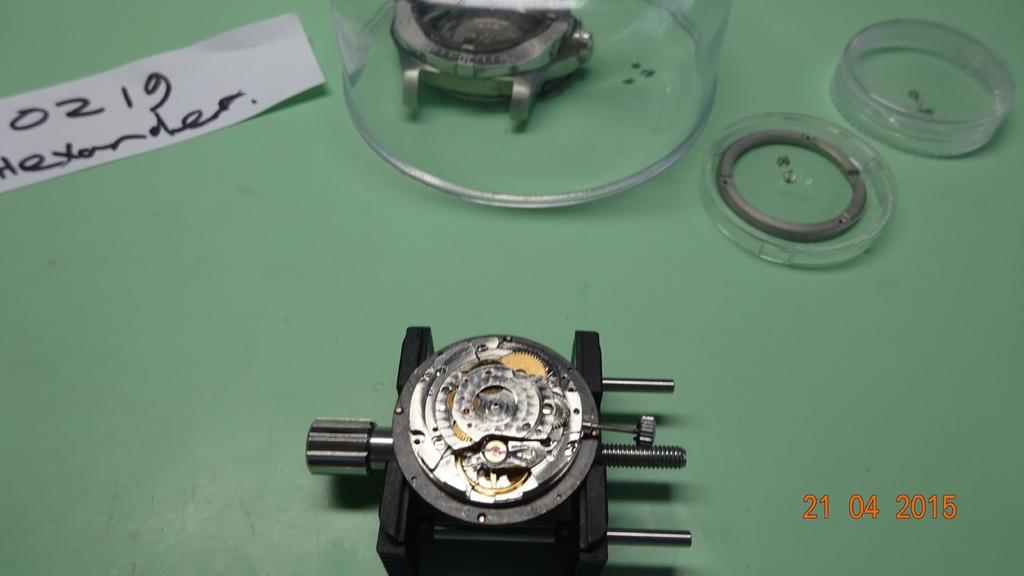<image>
Offer a succinct explanation of the picture presented. A watch that has been taken apart with a note for 0219 and possibly someone named Alexander. 